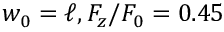<formula> <loc_0><loc_0><loc_500><loc_500>w _ { 0 } = \ell , F _ { z } / F _ { 0 } = 0 . 4 5</formula> 